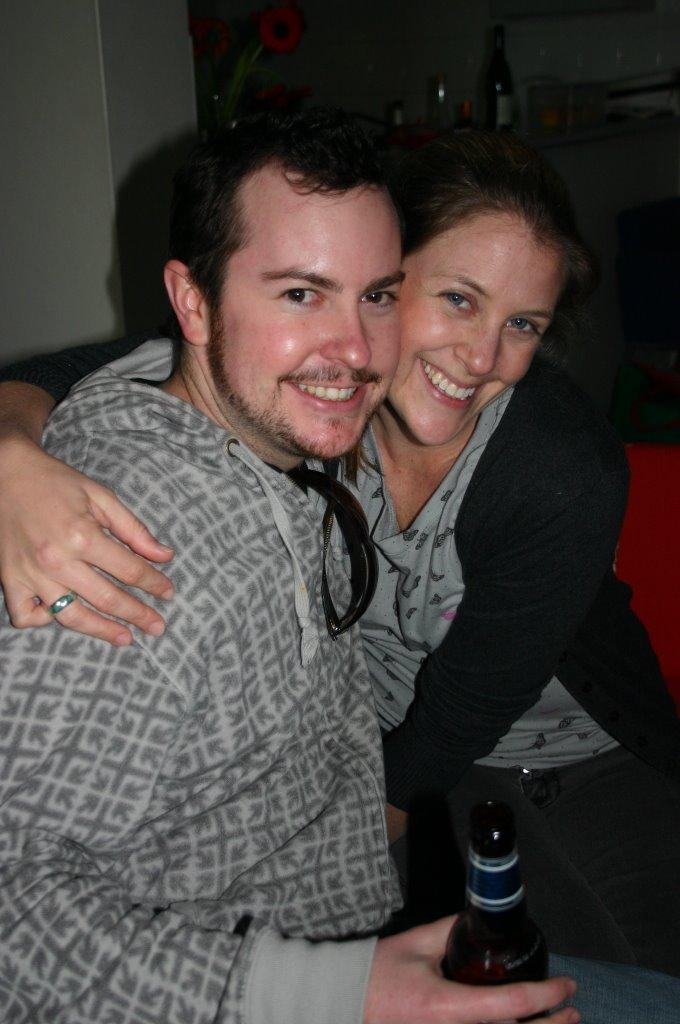How many people are in the image? There are two persons in the image. What is one person holding in the image? One person is holding a bottle. What can be seen in the background of the image? There is a wall and other objects visible in the background of the image. What type of thread is being used to fold the person's clothes in the image? There is no thread or folding of clothes present in the image. 